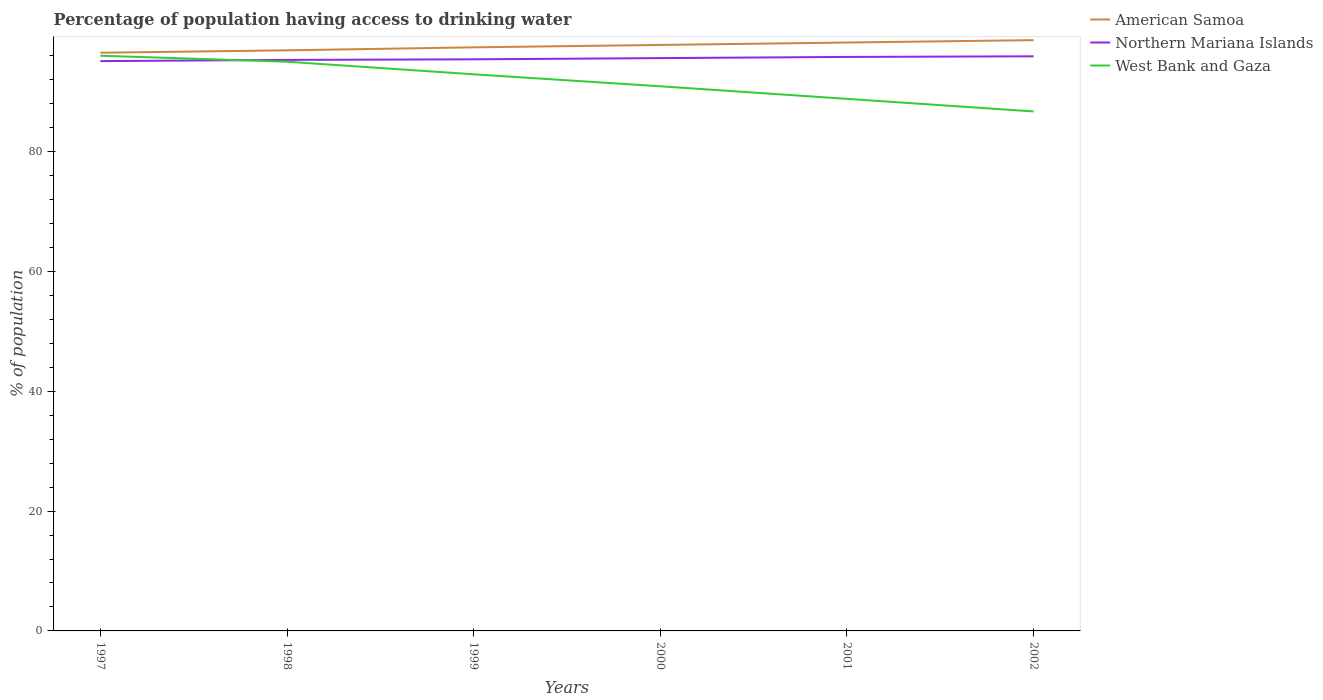Does the line corresponding to West Bank and Gaza intersect with the line corresponding to Northern Mariana Islands?
Offer a terse response. Yes. Across all years, what is the maximum percentage of population having access to drinking water in Northern Mariana Islands?
Offer a terse response. 95.1. In which year was the percentage of population having access to drinking water in American Samoa maximum?
Make the answer very short. 1997. What is the total percentage of population having access to drinking water in West Bank and Gaza in the graph?
Provide a succinct answer. 5.1. What is the difference between the highest and the second highest percentage of population having access to drinking water in West Bank and Gaza?
Your response must be concise. 9.3. What is the difference between the highest and the lowest percentage of population having access to drinking water in American Samoa?
Make the answer very short. 3. How many years are there in the graph?
Your answer should be very brief. 6. What is the difference between two consecutive major ticks on the Y-axis?
Offer a terse response. 20. Are the values on the major ticks of Y-axis written in scientific E-notation?
Your answer should be compact. No. Does the graph contain any zero values?
Your answer should be very brief. No. How many legend labels are there?
Give a very brief answer. 3. What is the title of the graph?
Offer a terse response. Percentage of population having access to drinking water. What is the label or title of the Y-axis?
Ensure brevity in your answer.  % of population. What is the % of population of American Samoa in 1997?
Your response must be concise. 96.5. What is the % of population in Northern Mariana Islands in 1997?
Keep it short and to the point. 95.1. What is the % of population of West Bank and Gaza in 1997?
Make the answer very short. 96. What is the % of population of American Samoa in 1998?
Keep it short and to the point. 96.9. What is the % of population in Northern Mariana Islands in 1998?
Provide a succinct answer. 95.3. What is the % of population in American Samoa in 1999?
Keep it short and to the point. 97.4. What is the % of population in Northern Mariana Islands in 1999?
Make the answer very short. 95.4. What is the % of population of West Bank and Gaza in 1999?
Keep it short and to the point. 92.9. What is the % of population of American Samoa in 2000?
Offer a terse response. 97.8. What is the % of population of Northern Mariana Islands in 2000?
Your response must be concise. 95.6. What is the % of population in West Bank and Gaza in 2000?
Your answer should be very brief. 90.9. What is the % of population in American Samoa in 2001?
Keep it short and to the point. 98.2. What is the % of population of Northern Mariana Islands in 2001?
Ensure brevity in your answer.  95.8. What is the % of population of West Bank and Gaza in 2001?
Your answer should be very brief. 88.8. What is the % of population in American Samoa in 2002?
Provide a short and direct response. 98.6. What is the % of population in Northern Mariana Islands in 2002?
Your answer should be very brief. 95.9. What is the % of population of West Bank and Gaza in 2002?
Your answer should be very brief. 86.7. Across all years, what is the maximum % of population in American Samoa?
Your answer should be compact. 98.6. Across all years, what is the maximum % of population in Northern Mariana Islands?
Your answer should be compact. 95.9. Across all years, what is the maximum % of population of West Bank and Gaza?
Offer a very short reply. 96. Across all years, what is the minimum % of population in American Samoa?
Make the answer very short. 96.5. Across all years, what is the minimum % of population in Northern Mariana Islands?
Offer a very short reply. 95.1. Across all years, what is the minimum % of population in West Bank and Gaza?
Make the answer very short. 86.7. What is the total % of population of American Samoa in the graph?
Offer a very short reply. 585.4. What is the total % of population of Northern Mariana Islands in the graph?
Offer a very short reply. 573.1. What is the total % of population in West Bank and Gaza in the graph?
Ensure brevity in your answer.  550.3. What is the difference between the % of population of Northern Mariana Islands in 1997 and that in 1998?
Provide a succinct answer. -0.2. What is the difference between the % of population of West Bank and Gaza in 1997 and that in 1998?
Your response must be concise. 1. What is the difference between the % of population of American Samoa in 1997 and that in 1999?
Your answer should be compact. -0.9. What is the difference between the % of population of West Bank and Gaza in 1997 and that in 1999?
Ensure brevity in your answer.  3.1. What is the difference between the % of population in American Samoa in 1997 and that in 2000?
Your response must be concise. -1.3. What is the difference between the % of population of Northern Mariana Islands in 1997 and that in 2000?
Give a very brief answer. -0.5. What is the difference between the % of population of Northern Mariana Islands in 1997 and that in 2001?
Offer a terse response. -0.7. What is the difference between the % of population of West Bank and Gaza in 1997 and that in 2002?
Offer a terse response. 9.3. What is the difference between the % of population in Northern Mariana Islands in 1998 and that in 1999?
Provide a succinct answer. -0.1. What is the difference between the % of population of West Bank and Gaza in 1998 and that in 1999?
Your answer should be very brief. 2.1. What is the difference between the % of population of West Bank and Gaza in 1998 and that in 2000?
Offer a terse response. 4.1. What is the difference between the % of population of American Samoa in 1998 and that in 2001?
Your answer should be very brief. -1.3. What is the difference between the % of population of West Bank and Gaza in 1998 and that in 2001?
Provide a short and direct response. 6.2. What is the difference between the % of population of West Bank and Gaza in 1998 and that in 2002?
Ensure brevity in your answer.  8.3. What is the difference between the % of population in American Samoa in 1999 and that in 2000?
Your answer should be very brief. -0.4. What is the difference between the % of population in Northern Mariana Islands in 1999 and that in 2001?
Provide a succinct answer. -0.4. What is the difference between the % of population in West Bank and Gaza in 1999 and that in 2001?
Provide a short and direct response. 4.1. What is the difference between the % of population in West Bank and Gaza in 1999 and that in 2002?
Make the answer very short. 6.2. What is the difference between the % of population of West Bank and Gaza in 2000 and that in 2002?
Offer a very short reply. 4.2. What is the difference between the % of population of West Bank and Gaza in 2001 and that in 2002?
Provide a succinct answer. 2.1. What is the difference between the % of population of American Samoa in 1997 and the % of population of West Bank and Gaza in 1999?
Provide a succinct answer. 3.6. What is the difference between the % of population in Northern Mariana Islands in 1997 and the % of population in West Bank and Gaza in 2000?
Provide a succinct answer. 4.2. What is the difference between the % of population of American Samoa in 1997 and the % of population of Northern Mariana Islands in 2001?
Provide a short and direct response. 0.7. What is the difference between the % of population in Northern Mariana Islands in 1997 and the % of population in West Bank and Gaza in 2001?
Keep it short and to the point. 6.3. What is the difference between the % of population of Northern Mariana Islands in 1998 and the % of population of West Bank and Gaza in 1999?
Make the answer very short. 2.4. What is the difference between the % of population in American Samoa in 1998 and the % of population in Northern Mariana Islands in 2000?
Offer a terse response. 1.3. What is the difference between the % of population in American Samoa in 1998 and the % of population in West Bank and Gaza in 2000?
Your answer should be very brief. 6. What is the difference between the % of population of Northern Mariana Islands in 1998 and the % of population of West Bank and Gaza in 2001?
Keep it short and to the point. 6.5. What is the difference between the % of population of American Samoa in 1998 and the % of population of West Bank and Gaza in 2002?
Ensure brevity in your answer.  10.2. What is the difference between the % of population of American Samoa in 1999 and the % of population of West Bank and Gaza in 2000?
Your answer should be compact. 6.5. What is the difference between the % of population in American Samoa in 1999 and the % of population in Northern Mariana Islands in 2001?
Offer a very short reply. 1.6. What is the difference between the % of population in American Samoa in 1999 and the % of population in West Bank and Gaza in 2001?
Keep it short and to the point. 8.6. What is the difference between the % of population of American Samoa in 1999 and the % of population of Northern Mariana Islands in 2002?
Provide a short and direct response. 1.5. What is the difference between the % of population of American Samoa in 2000 and the % of population of West Bank and Gaza in 2001?
Provide a short and direct response. 9. What is the difference between the % of population in Northern Mariana Islands in 2000 and the % of population in West Bank and Gaza in 2001?
Ensure brevity in your answer.  6.8. What is the difference between the % of population of American Samoa in 2000 and the % of population of West Bank and Gaza in 2002?
Offer a very short reply. 11.1. What is the difference between the % of population in American Samoa in 2001 and the % of population in Northern Mariana Islands in 2002?
Provide a succinct answer. 2.3. What is the difference between the % of population in American Samoa in 2001 and the % of population in West Bank and Gaza in 2002?
Keep it short and to the point. 11.5. What is the difference between the % of population of Northern Mariana Islands in 2001 and the % of population of West Bank and Gaza in 2002?
Provide a succinct answer. 9.1. What is the average % of population of American Samoa per year?
Offer a terse response. 97.57. What is the average % of population of Northern Mariana Islands per year?
Offer a very short reply. 95.52. What is the average % of population of West Bank and Gaza per year?
Give a very brief answer. 91.72. In the year 1997, what is the difference between the % of population in American Samoa and % of population in Northern Mariana Islands?
Give a very brief answer. 1.4. In the year 1997, what is the difference between the % of population of American Samoa and % of population of West Bank and Gaza?
Offer a terse response. 0.5. In the year 1998, what is the difference between the % of population of American Samoa and % of population of Northern Mariana Islands?
Provide a short and direct response. 1.6. In the year 1998, what is the difference between the % of population of Northern Mariana Islands and % of population of West Bank and Gaza?
Offer a very short reply. 0.3. In the year 1999, what is the difference between the % of population of American Samoa and % of population of West Bank and Gaza?
Make the answer very short. 4.5. In the year 2000, what is the difference between the % of population in American Samoa and % of population in Northern Mariana Islands?
Your answer should be very brief. 2.2. In the year 2000, what is the difference between the % of population of Northern Mariana Islands and % of population of West Bank and Gaza?
Give a very brief answer. 4.7. In the year 2001, what is the difference between the % of population of Northern Mariana Islands and % of population of West Bank and Gaza?
Your answer should be very brief. 7. In the year 2002, what is the difference between the % of population of American Samoa and % of population of West Bank and Gaza?
Make the answer very short. 11.9. What is the ratio of the % of population of Northern Mariana Islands in 1997 to that in 1998?
Your answer should be compact. 1. What is the ratio of the % of population in West Bank and Gaza in 1997 to that in 1998?
Your answer should be compact. 1.01. What is the ratio of the % of population of Northern Mariana Islands in 1997 to that in 1999?
Your answer should be very brief. 1. What is the ratio of the % of population of West Bank and Gaza in 1997 to that in 1999?
Provide a short and direct response. 1.03. What is the ratio of the % of population of American Samoa in 1997 to that in 2000?
Keep it short and to the point. 0.99. What is the ratio of the % of population of West Bank and Gaza in 1997 to that in 2000?
Offer a terse response. 1.06. What is the ratio of the % of population in American Samoa in 1997 to that in 2001?
Your response must be concise. 0.98. What is the ratio of the % of population of Northern Mariana Islands in 1997 to that in 2001?
Give a very brief answer. 0.99. What is the ratio of the % of population in West Bank and Gaza in 1997 to that in 2001?
Ensure brevity in your answer.  1.08. What is the ratio of the % of population of American Samoa in 1997 to that in 2002?
Give a very brief answer. 0.98. What is the ratio of the % of population in West Bank and Gaza in 1997 to that in 2002?
Offer a very short reply. 1.11. What is the ratio of the % of population of West Bank and Gaza in 1998 to that in 1999?
Give a very brief answer. 1.02. What is the ratio of the % of population of West Bank and Gaza in 1998 to that in 2000?
Keep it short and to the point. 1.05. What is the ratio of the % of population of Northern Mariana Islands in 1998 to that in 2001?
Ensure brevity in your answer.  0.99. What is the ratio of the % of population in West Bank and Gaza in 1998 to that in 2001?
Offer a very short reply. 1.07. What is the ratio of the % of population of American Samoa in 1998 to that in 2002?
Provide a succinct answer. 0.98. What is the ratio of the % of population of Northern Mariana Islands in 1998 to that in 2002?
Offer a very short reply. 0.99. What is the ratio of the % of population in West Bank and Gaza in 1998 to that in 2002?
Give a very brief answer. 1.1. What is the ratio of the % of population in West Bank and Gaza in 1999 to that in 2001?
Provide a succinct answer. 1.05. What is the ratio of the % of population of American Samoa in 1999 to that in 2002?
Ensure brevity in your answer.  0.99. What is the ratio of the % of population of West Bank and Gaza in 1999 to that in 2002?
Give a very brief answer. 1.07. What is the ratio of the % of population of American Samoa in 2000 to that in 2001?
Give a very brief answer. 1. What is the ratio of the % of population in West Bank and Gaza in 2000 to that in 2001?
Offer a very short reply. 1.02. What is the ratio of the % of population of American Samoa in 2000 to that in 2002?
Your answer should be very brief. 0.99. What is the ratio of the % of population of West Bank and Gaza in 2000 to that in 2002?
Keep it short and to the point. 1.05. What is the ratio of the % of population in West Bank and Gaza in 2001 to that in 2002?
Offer a very short reply. 1.02. What is the difference between the highest and the second highest % of population of American Samoa?
Offer a terse response. 0.4. What is the difference between the highest and the second highest % of population of West Bank and Gaza?
Offer a terse response. 1. 